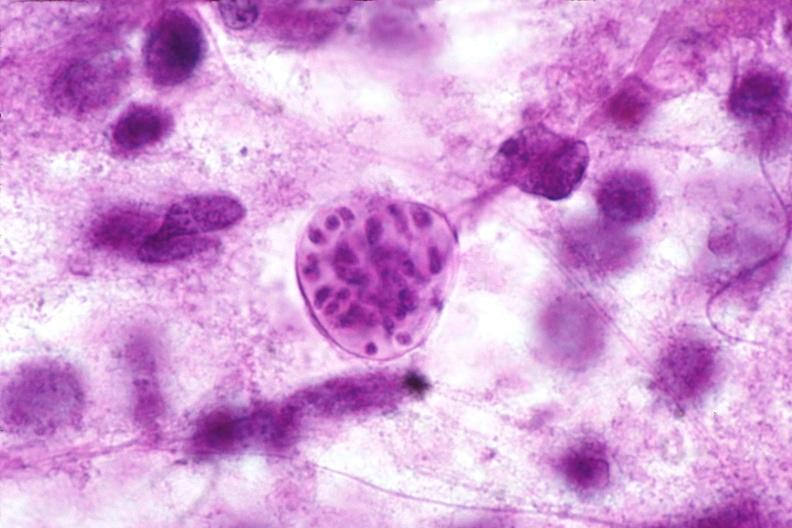what is present?
Answer the question using a single word or phrase. Nervous 